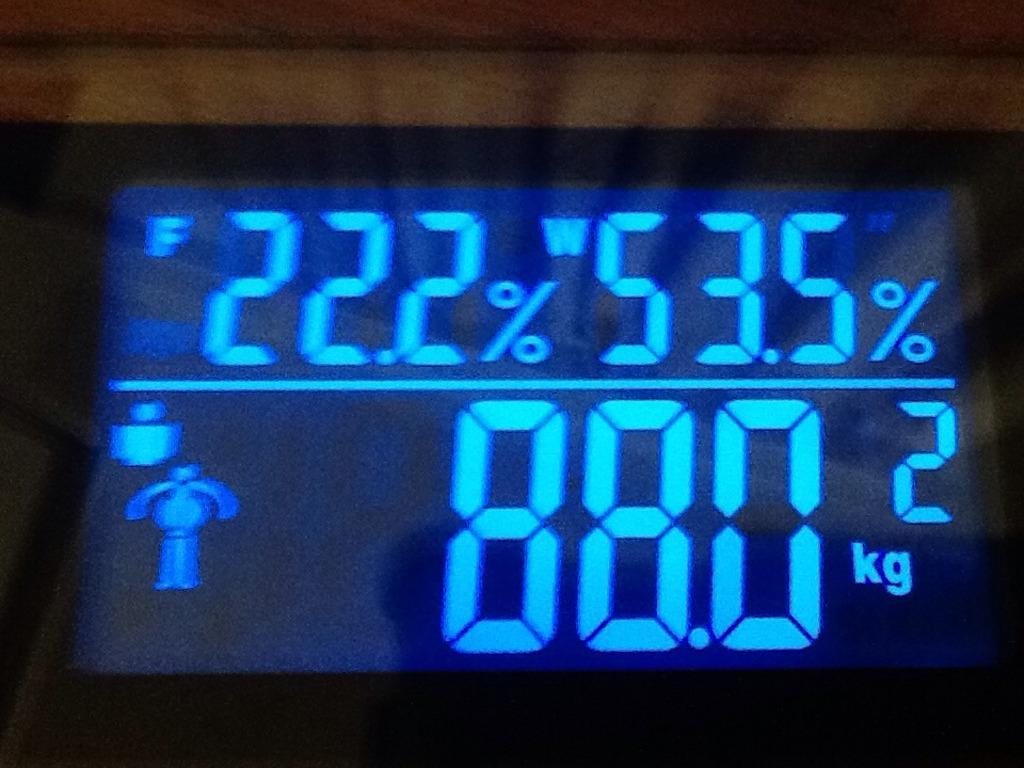How much does this person weigh in kilograms?
Ensure brevity in your answer.  88. What is the percentage shown on the top left?
Keep it short and to the point. 22.2. 